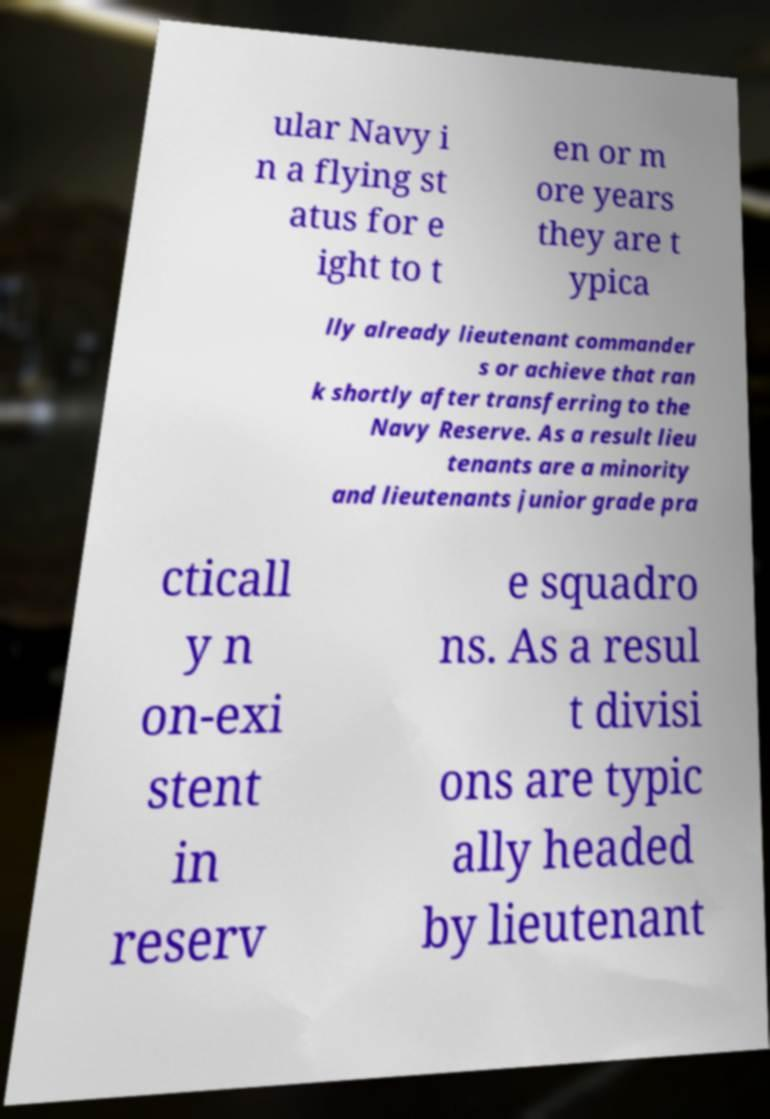Please read and relay the text visible in this image. What does it say? ular Navy i n a flying st atus for e ight to t en or m ore years they are t ypica lly already lieutenant commander s or achieve that ran k shortly after transferring to the Navy Reserve. As a result lieu tenants are a minority and lieutenants junior grade pra cticall y n on-exi stent in reserv e squadro ns. As a resul t divisi ons are typic ally headed by lieutenant 